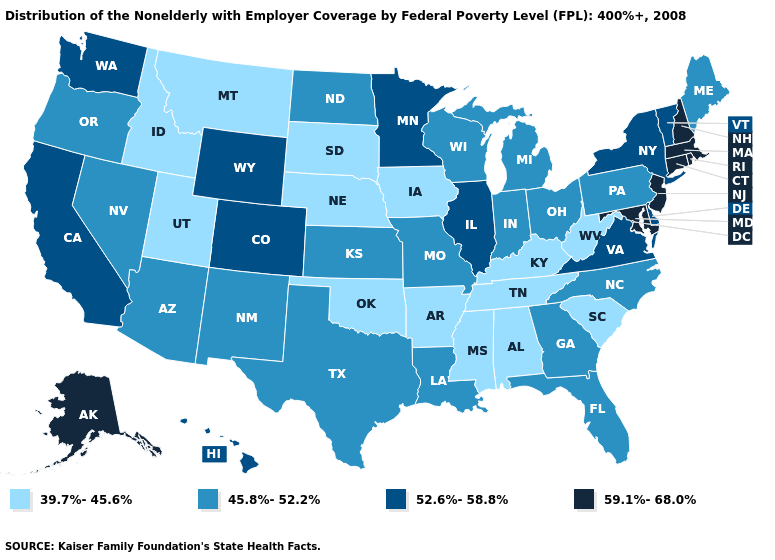Which states have the lowest value in the MidWest?
Answer briefly. Iowa, Nebraska, South Dakota. Among the states that border Maine , which have the highest value?
Concise answer only. New Hampshire. Does Arkansas have the highest value in the South?
Answer briefly. No. Name the states that have a value in the range 45.8%-52.2%?
Concise answer only. Arizona, Florida, Georgia, Indiana, Kansas, Louisiana, Maine, Michigan, Missouri, Nevada, New Mexico, North Carolina, North Dakota, Ohio, Oregon, Pennsylvania, Texas, Wisconsin. What is the value of Arkansas?
Give a very brief answer. 39.7%-45.6%. Does the map have missing data?
Be succinct. No. How many symbols are there in the legend?
Keep it brief. 4. Is the legend a continuous bar?
Give a very brief answer. No. Is the legend a continuous bar?
Short answer required. No. What is the highest value in the USA?
Answer briefly. 59.1%-68.0%. Name the states that have a value in the range 39.7%-45.6%?
Keep it brief. Alabama, Arkansas, Idaho, Iowa, Kentucky, Mississippi, Montana, Nebraska, Oklahoma, South Carolina, South Dakota, Tennessee, Utah, West Virginia. What is the value of Michigan?
Write a very short answer. 45.8%-52.2%. Does Louisiana have a higher value than California?
Give a very brief answer. No. Does New Jersey have the highest value in the Northeast?
Short answer required. Yes. What is the lowest value in the USA?
Quick response, please. 39.7%-45.6%. 